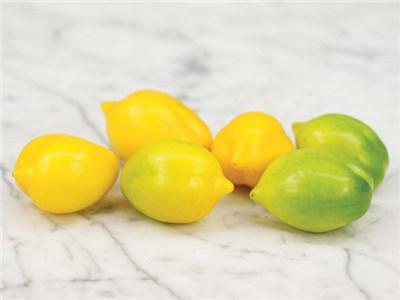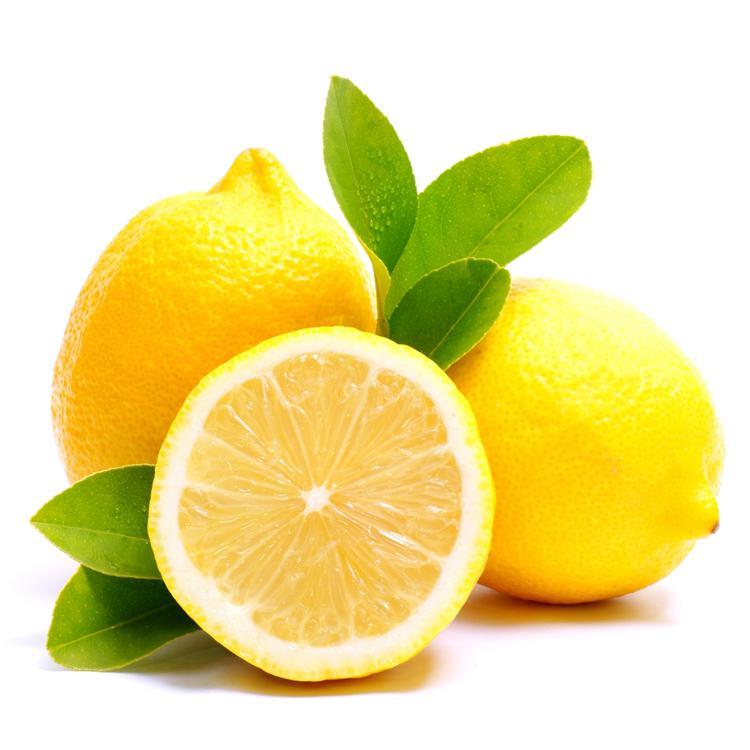The first image is the image on the left, the second image is the image on the right. Assess this claim about the two images: "An image without a beverage in a glass contains a whole tomato, whole lemons with green leaf, and a half lemon.". Correct or not? Answer yes or no. No. The first image is the image on the left, the second image is the image on the right. For the images displayed, is the sentence "In the left image, there are the same number of lemons and tomatoes." factually correct? Answer yes or no. No. 